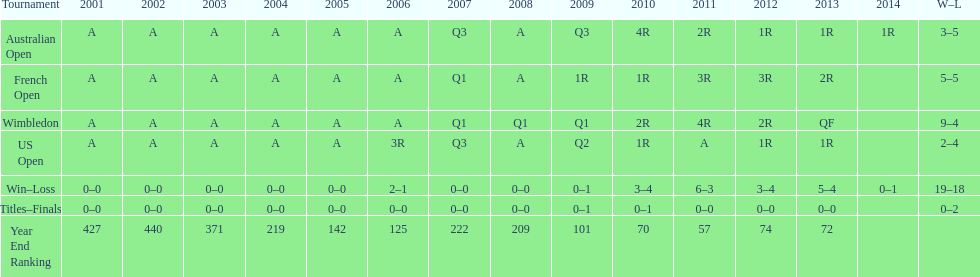Which year end ranking was higher, 2004 or 2011? 2011. 